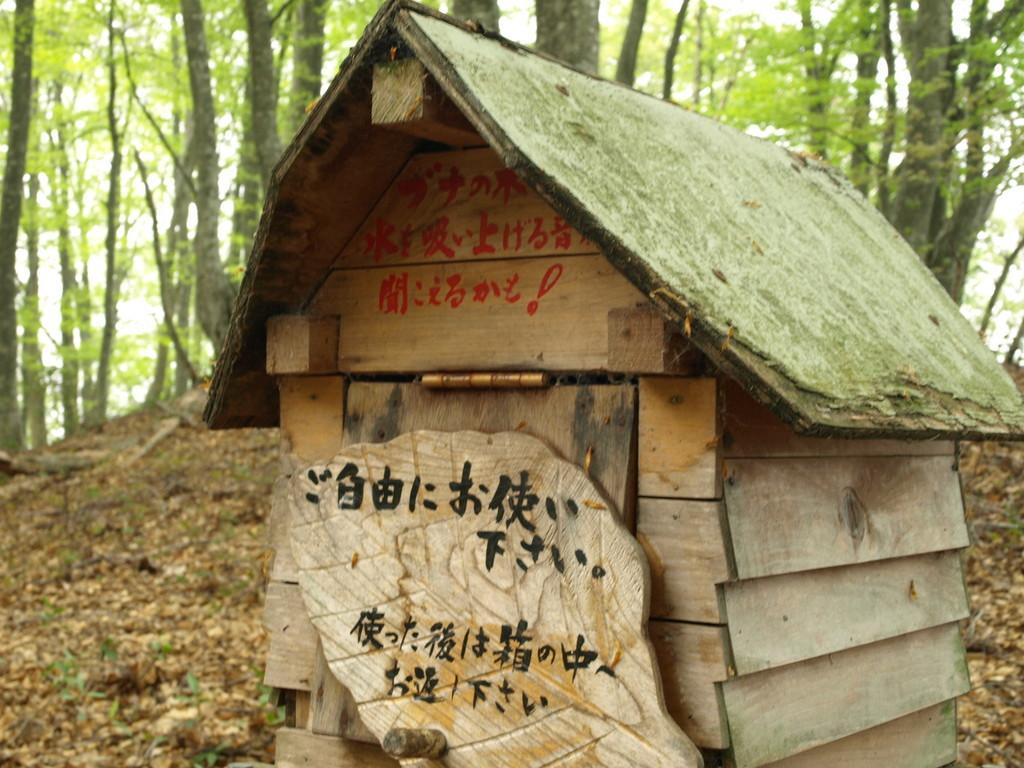Please provide a concise description of this image. This picture shows a wooden hut and we see trees and few leaves on the ground. 